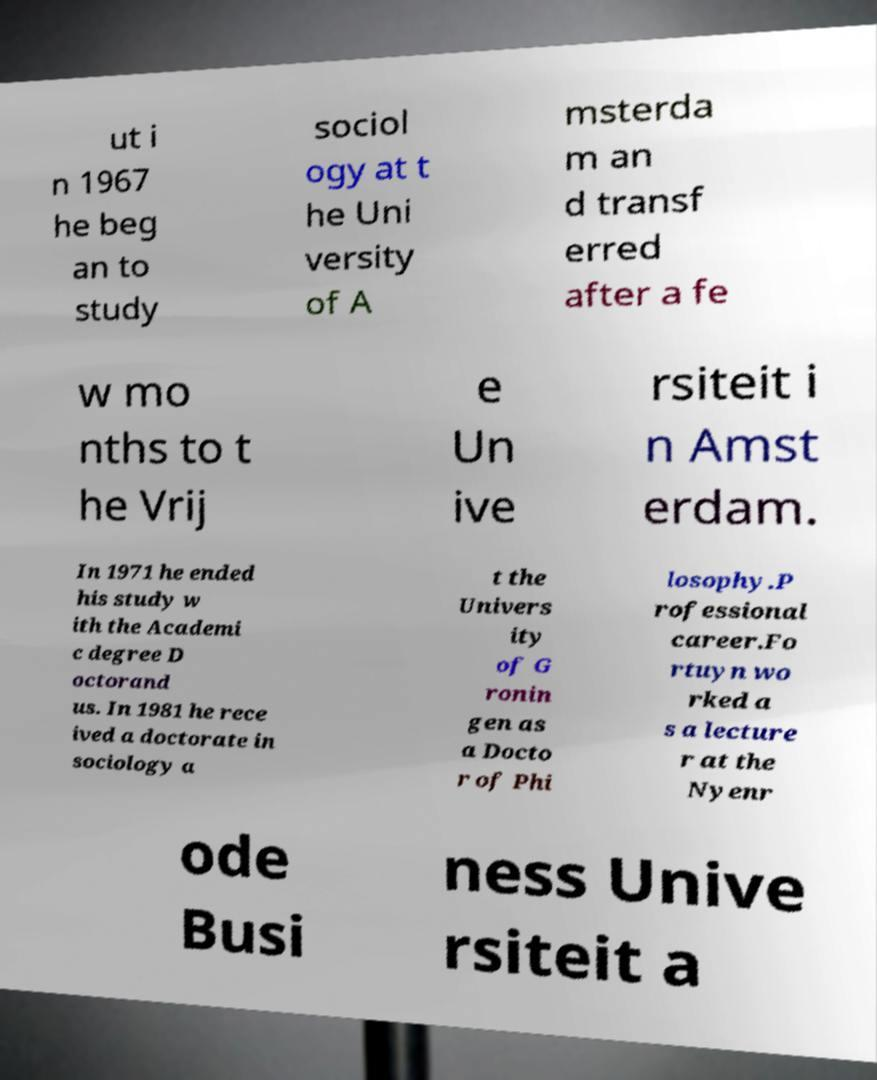What messages or text are displayed in this image? I need them in a readable, typed format. ut i n 1967 he beg an to study sociol ogy at t he Uni versity of A msterda m an d transf erred after a fe w mo nths to t he Vrij e Un ive rsiteit i n Amst erdam. In 1971 he ended his study w ith the Academi c degree D octorand us. In 1981 he rece ived a doctorate in sociology a t the Univers ity of G ronin gen as a Docto r of Phi losophy.P rofessional career.Fo rtuyn wo rked a s a lecture r at the Nyenr ode Busi ness Unive rsiteit a 